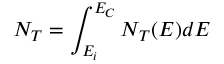<formula> <loc_0><loc_0><loc_500><loc_500>N _ { T } = \int _ { E _ { i } } ^ { E _ { C } } N _ { T } ( E ) d E</formula> 